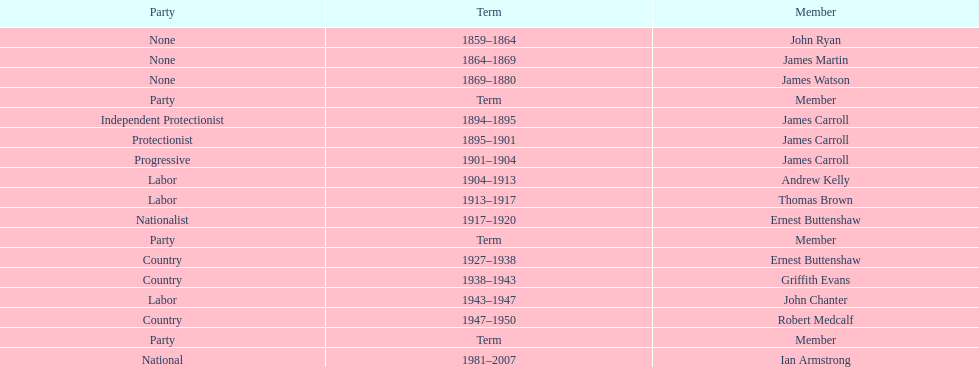Of the members of the third incarnation of the lachlan, who served the longest? Ernest Buttenshaw. 